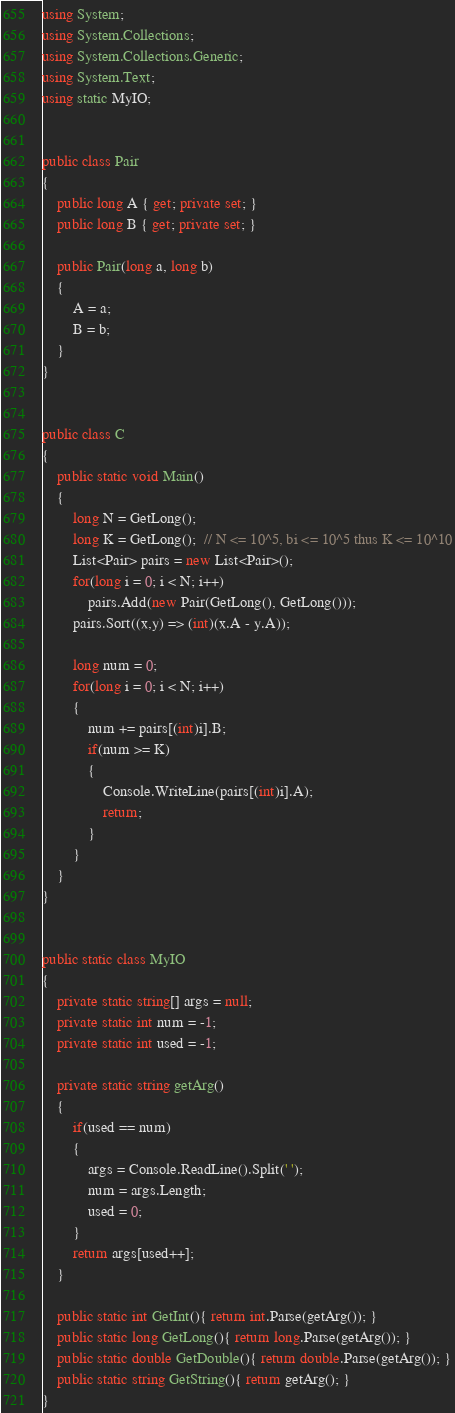Convert code to text. <code><loc_0><loc_0><loc_500><loc_500><_C#_>using System;
using System.Collections;
using System.Collections.Generic;
using System.Text;
using static MyIO;


public class Pair
{
	public long A { get; private set; }
	public long B { get; private set; }

	public Pair(long a, long b)
	{
		A = a;
		B = b;
	}
}


public class C
{
	public static void Main()	
	{
		long N = GetLong();
		long K = GetLong();  // N <= 10^5, bi <= 10^5 thus K <= 10^10
		List<Pair> pairs = new List<Pair>();
		for(long i = 0; i < N; i++)
			pairs.Add(new Pair(GetLong(), GetLong()));
		pairs.Sort((x,y) => (int)(x.A - y.A));

		long num = 0;
		for(long i = 0; i < N; i++)
		{
			num += pairs[(int)i].B;
			if(num >= K)
			{
				Console.WriteLine(pairs[(int)i].A);
				return;
			}
		}
	}
}


public static class MyIO
{
	private static string[] args = null;
	private static int num = -1;
	private static int used = -1;

	private static string getArg()
	{
		if(used == num)
		{
			args = Console.ReadLine().Split(' ');
			num = args.Length;
			used = 0;
		}
		return args[used++];
	}

	public static int GetInt(){ return int.Parse(getArg()); }
	public static long GetLong(){ return long.Parse(getArg()); }
	public static double GetDouble(){ return double.Parse(getArg()); }
	public static string GetString(){ return getArg(); }
}
</code> 